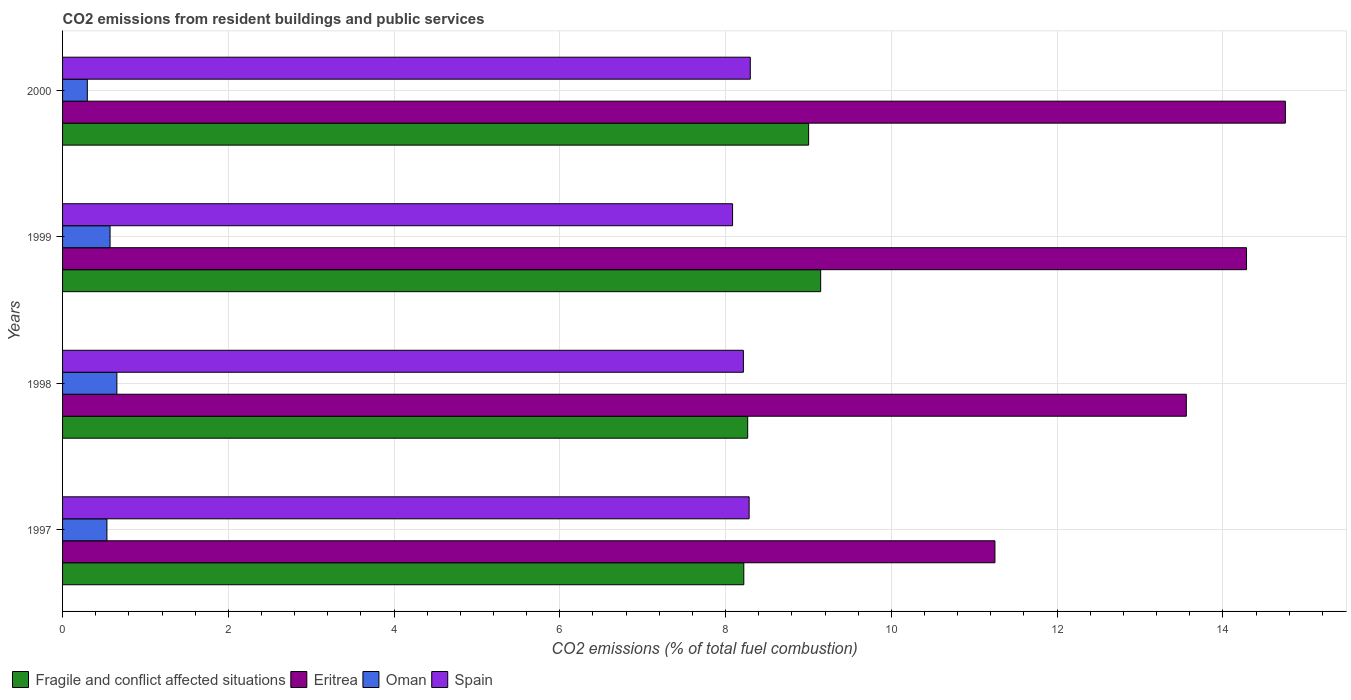How many different coloured bars are there?
Keep it short and to the point. 4. Are the number of bars per tick equal to the number of legend labels?
Your answer should be compact. Yes. Are the number of bars on each tick of the Y-axis equal?
Your answer should be compact. Yes. What is the label of the 1st group of bars from the top?
Offer a very short reply. 2000. What is the total CO2 emitted in Oman in 1999?
Your response must be concise. 0.57. Across all years, what is the maximum total CO2 emitted in Fragile and conflict affected situations?
Your answer should be very brief. 9.15. Across all years, what is the minimum total CO2 emitted in Oman?
Give a very brief answer. 0.3. In which year was the total CO2 emitted in Spain maximum?
Ensure brevity in your answer.  2000. What is the total total CO2 emitted in Oman in the graph?
Ensure brevity in your answer.  2.06. What is the difference between the total CO2 emitted in Eritrea in 1997 and that in 1999?
Your answer should be very brief. -3.04. What is the difference between the total CO2 emitted in Oman in 1998 and the total CO2 emitted in Eritrea in 1999?
Provide a succinct answer. -13.63. What is the average total CO2 emitted in Fragile and conflict affected situations per year?
Your answer should be compact. 8.66. In the year 1999, what is the difference between the total CO2 emitted in Spain and total CO2 emitted in Fragile and conflict affected situations?
Your response must be concise. -1.06. In how many years, is the total CO2 emitted in Spain greater than 2.8 ?
Provide a short and direct response. 4. What is the ratio of the total CO2 emitted in Oman in 1999 to that in 2000?
Offer a very short reply. 1.92. Is the total CO2 emitted in Eritrea in 1997 less than that in 1999?
Offer a terse response. Yes. What is the difference between the highest and the second highest total CO2 emitted in Fragile and conflict affected situations?
Offer a very short reply. 0.15. What is the difference between the highest and the lowest total CO2 emitted in Fragile and conflict affected situations?
Your response must be concise. 0.93. In how many years, is the total CO2 emitted in Oman greater than the average total CO2 emitted in Oman taken over all years?
Keep it short and to the point. 3. What does the 1st bar from the top in 1999 represents?
Give a very brief answer. Spain. What does the 2nd bar from the bottom in 1998 represents?
Keep it short and to the point. Eritrea. How many years are there in the graph?
Give a very brief answer. 4. Are the values on the major ticks of X-axis written in scientific E-notation?
Your response must be concise. No. Does the graph contain grids?
Provide a short and direct response. Yes. Where does the legend appear in the graph?
Ensure brevity in your answer.  Bottom left. How are the legend labels stacked?
Provide a succinct answer. Horizontal. What is the title of the graph?
Provide a short and direct response. CO2 emissions from resident buildings and public services. What is the label or title of the X-axis?
Make the answer very short. CO2 emissions (% of total fuel combustion). What is the label or title of the Y-axis?
Ensure brevity in your answer.  Years. What is the CO2 emissions (% of total fuel combustion) in Fragile and conflict affected situations in 1997?
Your answer should be compact. 8.22. What is the CO2 emissions (% of total fuel combustion) of Eritrea in 1997?
Your answer should be compact. 11.25. What is the CO2 emissions (% of total fuel combustion) in Oman in 1997?
Provide a short and direct response. 0.54. What is the CO2 emissions (% of total fuel combustion) of Spain in 1997?
Your answer should be very brief. 8.28. What is the CO2 emissions (% of total fuel combustion) of Fragile and conflict affected situations in 1998?
Keep it short and to the point. 8.27. What is the CO2 emissions (% of total fuel combustion) of Eritrea in 1998?
Your response must be concise. 13.56. What is the CO2 emissions (% of total fuel combustion) in Oman in 1998?
Provide a succinct answer. 0.66. What is the CO2 emissions (% of total fuel combustion) in Spain in 1998?
Keep it short and to the point. 8.21. What is the CO2 emissions (% of total fuel combustion) of Fragile and conflict affected situations in 1999?
Ensure brevity in your answer.  9.15. What is the CO2 emissions (% of total fuel combustion) in Eritrea in 1999?
Your answer should be very brief. 14.29. What is the CO2 emissions (% of total fuel combustion) in Oman in 1999?
Your answer should be very brief. 0.57. What is the CO2 emissions (% of total fuel combustion) of Spain in 1999?
Make the answer very short. 8.08. What is the CO2 emissions (% of total fuel combustion) in Fragile and conflict affected situations in 2000?
Offer a terse response. 9. What is the CO2 emissions (% of total fuel combustion) in Eritrea in 2000?
Give a very brief answer. 14.75. What is the CO2 emissions (% of total fuel combustion) of Oman in 2000?
Provide a succinct answer. 0.3. What is the CO2 emissions (% of total fuel combustion) of Spain in 2000?
Your answer should be compact. 8.3. Across all years, what is the maximum CO2 emissions (% of total fuel combustion) of Fragile and conflict affected situations?
Your response must be concise. 9.15. Across all years, what is the maximum CO2 emissions (% of total fuel combustion) of Eritrea?
Offer a very short reply. 14.75. Across all years, what is the maximum CO2 emissions (% of total fuel combustion) in Oman?
Provide a short and direct response. 0.66. Across all years, what is the maximum CO2 emissions (% of total fuel combustion) of Spain?
Offer a terse response. 8.3. Across all years, what is the minimum CO2 emissions (% of total fuel combustion) of Fragile and conflict affected situations?
Offer a very short reply. 8.22. Across all years, what is the minimum CO2 emissions (% of total fuel combustion) of Eritrea?
Offer a very short reply. 11.25. Across all years, what is the minimum CO2 emissions (% of total fuel combustion) of Oman?
Your response must be concise. 0.3. Across all years, what is the minimum CO2 emissions (% of total fuel combustion) in Spain?
Your answer should be very brief. 8.08. What is the total CO2 emissions (% of total fuel combustion) in Fragile and conflict affected situations in the graph?
Provide a short and direct response. 34.64. What is the total CO2 emissions (% of total fuel combustion) in Eritrea in the graph?
Offer a very short reply. 53.85. What is the total CO2 emissions (% of total fuel combustion) in Oman in the graph?
Make the answer very short. 2.06. What is the total CO2 emissions (% of total fuel combustion) in Spain in the graph?
Keep it short and to the point. 32.88. What is the difference between the CO2 emissions (% of total fuel combustion) of Fragile and conflict affected situations in 1997 and that in 1998?
Make the answer very short. -0.05. What is the difference between the CO2 emissions (% of total fuel combustion) of Eritrea in 1997 and that in 1998?
Offer a terse response. -2.31. What is the difference between the CO2 emissions (% of total fuel combustion) of Oman in 1997 and that in 1998?
Keep it short and to the point. -0.12. What is the difference between the CO2 emissions (% of total fuel combustion) in Spain in 1997 and that in 1998?
Your response must be concise. 0.07. What is the difference between the CO2 emissions (% of total fuel combustion) in Fragile and conflict affected situations in 1997 and that in 1999?
Offer a terse response. -0.93. What is the difference between the CO2 emissions (% of total fuel combustion) of Eritrea in 1997 and that in 1999?
Offer a terse response. -3.04. What is the difference between the CO2 emissions (% of total fuel combustion) in Oman in 1997 and that in 1999?
Your answer should be very brief. -0.04. What is the difference between the CO2 emissions (% of total fuel combustion) of Spain in 1997 and that in 1999?
Ensure brevity in your answer.  0.2. What is the difference between the CO2 emissions (% of total fuel combustion) of Fragile and conflict affected situations in 1997 and that in 2000?
Your response must be concise. -0.78. What is the difference between the CO2 emissions (% of total fuel combustion) in Eritrea in 1997 and that in 2000?
Keep it short and to the point. -3.5. What is the difference between the CO2 emissions (% of total fuel combustion) of Oman in 1997 and that in 2000?
Offer a terse response. 0.24. What is the difference between the CO2 emissions (% of total fuel combustion) in Spain in 1997 and that in 2000?
Your answer should be compact. -0.01. What is the difference between the CO2 emissions (% of total fuel combustion) of Fragile and conflict affected situations in 1998 and that in 1999?
Give a very brief answer. -0.88. What is the difference between the CO2 emissions (% of total fuel combustion) of Eritrea in 1998 and that in 1999?
Offer a very short reply. -0.73. What is the difference between the CO2 emissions (% of total fuel combustion) in Oman in 1998 and that in 1999?
Give a very brief answer. 0.08. What is the difference between the CO2 emissions (% of total fuel combustion) in Spain in 1998 and that in 1999?
Your answer should be very brief. 0.13. What is the difference between the CO2 emissions (% of total fuel combustion) of Fragile and conflict affected situations in 1998 and that in 2000?
Your answer should be very brief. -0.74. What is the difference between the CO2 emissions (% of total fuel combustion) in Eritrea in 1998 and that in 2000?
Provide a short and direct response. -1.19. What is the difference between the CO2 emissions (% of total fuel combustion) of Oman in 1998 and that in 2000?
Your response must be concise. 0.36. What is the difference between the CO2 emissions (% of total fuel combustion) of Spain in 1998 and that in 2000?
Ensure brevity in your answer.  -0.08. What is the difference between the CO2 emissions (% of total fuel combustion) of Fragile and conflict affected situations in 1999 and that in 2000?
Keep it short and to the point. 0.15. What is the difference between the CO2 emissions (% of total fuel combustion) of Eritrea in 1999 and that in 2000?
Your answer should be very brief. -0.47. What is the difference between the CO2 emissions (% of total fuel combustion) in Oman in 1999 and that in 2000?
Provide a short and direct response. 0.27. What is the difference between the CO2 emissions (% of total fuel combustion) in Spain in 1999 and that in 2000?
Provide a short and direct response. -0.21. What is the difference between the CO2 emissions (% of total fuel combustion) in Fragile and conflict affected situations in 1997 and the CO2 emissions (% of total fuel combustion) in Eritrea in 1998?
Your response must be concise. -5.34. What is the difference between the CO2 emissions (% of total fuel combustion) in Fragile and conflict affected situations in 1997 and the CO2 emissions (% of total fuel combustion) in Oman in 1998?
Provide a succinct answer. 7.56. What is the difference between the CO2 emissions (% of total fuel combustion) of Fragile and conflict affected situations in 1997 and the CO2 emissions (% of total fuel combustion) of Spain in 1998?
Provide a short and direct response. 0.01. What is the difference between the CO2 emissions (% of total fuel combustion) of Eritrea in 1997 and the CO2 emissions (% of total fuel combustion) of Oman in 1998?
Provide a short and direct response. 10.59. What is the difference between the CO2 emissions (% of total fuel combustion) in Eritrea in 1997 and the CO2 emissions (% of total fuel combustion) in Spain in 1998?
Make the answer very short. 3.04. What is the difference between the CO2 emissions (% of total fuel combustion) in Oman in 1997 and the CO2 emissions (% of total fuel combustion) in Spain in 1998?
Your answer should be compact. -7.68. What is the difference between the CO2 emissions (% of total fuel combustion) of Fragile and conflict affected situations in 1997 and the CO2 emissions (% of total fuel combustion) of Eritrea in 1999?
Ensure brevity in your answer.  -6.07. What is the difference between the CO2 emissions (% of total fuel combustion) in Fragile and conflict affected situations in 1997 and the CO2 emissions (% of total fuel combustion) in Oman in 1999?
Your answer should be compact. 7.65. What is the difference between the CO2 emissions (% of total fuel combustion) in Fragile and conflict affected situations in 1997 and the CO2 emissions (% of total fuel combustion) in Spain in 1999?
Provide a succinct answer. 0.14. What is the difference between the CO2 emissions (% of total fuel combustion) in Eritrea in 1997 and the CO2 emissions (% of total fuel combustion) in Oman in 1999?
Ensure brevity in your answer.  10.68. What is the difference between the CO2 emissions (% of total fuel combustion) of Eritrea in 1997 and the CO2 emissions (% of total fuel combustion) of Spain in 1999?
Offer a terse response. 3.17. What is the difference between the CO2 emissions (% of total fuel combustion) of Oman in 1997 and the CO2 emissions (% of total fuel combustion) of Spain in 1999?
Your answer should be very brief. -7.55. What is the difference between the CO2 emissions (% of total fuel combustion) of Fragile and conflict affected situations in 1997 and the CO2 emissions (% of total fuel combustion) of Eritrea in 2000?
Make the answer very short. -6.53. What is the difference between the CO2 emissions (% of total fuel combustion) in Fragile and conflict affected situations in 1997 and the CO2 emissions (% of total fuel combustion) in Oman in 2000?
Your answer should be compact. 7.92. What is the difference between the CO2 emissions (% of total fuel combustion) in Fragile and conflict affected situations in 1997 and the CO2 emissions (% of total fuel combustion) in Spain in 2000?
Ensure brevity in your answer.  -0.08. What is the difference between the CO2 emissions (% of total fuel combustion) of Eritrea in 1997 and the CO2 emissions (% of total fuel combustion) of Oman in 2000?
Give a very brief answer. 10.95. What is the difference between the CO2 emissions (% of total fuel combustion) of Eritrea in 1997 and the CO2 emissions (% of total fuel combustion) of Spain in 2000?
Give a very brief answer. 2.95. What is the difference between the CO2 emissions (% of total fuel combustion) in Oman in 1997 and the CO2 emissions (% of total fuel combustion) in Spain in 2000?
Your response must be concise. -7.76. What is the difference between the CO2 emissions (% of total fuel combustion) in Fragile and conflict affected situations in 1998 and the CO2 emissions (% of total fuel combustion) in Eritrea in 1999?
Your response must be concise. -6.02. What is the difference between the CO2 emissions (% of total fuel combustion) in Fragile and conflict affected situations in 1998 and the CO2 emissions (% of total fuel combustion) in Oman in 1999?
Your response must be concise. 7.69. What is the difference between the CO2 emissions (% of total fuel combustion) in Fragile and conflict affected situations in 1998 and the CO2 emissions (% of total fuel combustion) in Spain in 1999?
Offer a very short reply. 0.18. What is the difference between the CO2 emissions (% of total fuel combustion) of Eritrea in 1998 and the CO2 emissions (% of total fuel combustion) of Oman in 1999?
Keep it short and to the point. 12.99. What is the difference between the CO2 emissions (% of total fuel combustion) in Eritrea in 1998 and the CO2 emissions (% of total fuel combustion) in Spain in 1999?
Ensure brevity in your answer.  5.47. What is the difference between the CO2 emissions (% of total fuel combustion) in Oman in 1998 and the CO2 emissions (% of total fuel combustion) in Spain in 1999?
Provide a short and direct response. -7.43. What is the difference between the CO2 emissions (% of total fuel combustion) of Fragile and conflict affected situations in 1998 and the CO2 emissions (% of total fuel combustion) of Eritrea in 2000?
Ensure brevity in your answer.  -6.49. What is the difference between the CO2 emissions (% of total fuel combustion) in Fragile and conflict affected situations in 1998 and the CO2 emissions (% of total fuel combustion) in Oman in 2000?
Offer a terse response. 7.97. What is the difference between the CO2 emissions (% of total fuel combustion) of Fragile and conflict affected situations in 1998 and the CO2 emissions (% of total fuel combustion) of Spain in 2000?
Provide a short and direct response. -0.03. What is the difference between the CO2 emissions (% of total fuel combustion) of Eritrea in 1998 and the CO2 emissions (% of total fuel combustion) of Oman in 2000?
Give a very brief answer. 13.26. What is the difference between the CO2 emissions (% of total fuel combustion) of Eritrea in 1998 and the CO2 emissions (% of total fuel combustion) of Spain in 2000?
Make the answer very short. 5.26. What is the difference between the CO2 emissions (% of total fuel combustion) in Oman in 1998 and the CO2 emissions (% of total fuel combustion) in Spain in 2000?
Keep it short and to the point. -7.64. What is the difference between the CO2 emissions (% of total fuel combustion) of Fragile and conflict affected situations in 1999 and the CO2 emissions (% of total fuel combustion) of Eritrea in 2000?
Your answer should be compact. -5.61. What is the difference between the CO2 emissions (% of total fuel combustion) in Fragile and conflict affected situations in 1999 and the CO2 emissions (% of total fuel combustion) in Oman in 2000?
Offer a very short reply. 8.85. What is the difference between the CO2 emissions (% of total fuel combustion) of Fragile and conflict affected situations in 1999 and the CO2 emissions (% of total fuel combustion) of Spain in 2000?
Your response must be concise. 0.85. What is the difference between the CO2 emissions (% of total fuel combustion) in Eritrea in 1999 and the CO2 emissions (% of total fuel combustion) in Oman in 2000?
Keep it short and to the point. 13.99. What is the difference between the CO2 emissions (% of total fuel combustion) in Eritrea in 1999 and the CO2 emissions (% of total fuel combustion) in Spain in 2000?
Your answer should be very brief. 5.99. What is the difference between the CO2 emissions (% of total fuel combustion) in Oman in 1999 and the CO2 emissions (% of total fuel combustion) in Spain in 2000?
Make the answer very short. -7.72. What is the average CO2 emissions (% of total fuel combustion) in Fragile and conflict affected situations per year?
Your answer should be very brief. 8.66. What is the average CO2 emissions (% of total fuel combustion) of Eritrea per year?
Make the answer very short. 13.46. What is the average CO2 emissions (% of total fuel combustion) in Oman per year?
Provide a succinct answer. 0.52. What is the average CO2 emissions (% of total fuel combustion) in Spain per year?
Your answer should be very brief. 8.22. In the year 1997, what is the difference between the CO2 emissions (% of total fuel combustion) of Fragile and conflict affected situations and CO2 emissions (% of total fuel combustion) of Eritrea?
Keep it short and to the point. -3.03. In the year 1997, what is the difference between the CO2 emissions (% of total fuel combustion) in Fragile and conflict affected situations and CO2 emissions (% of total fuel combustion) in Oman?
Give a very brief answer. 7.68. In the year 1997, what is the difference between the CO2 emissions (% of total fuel combustion) of Fragile and conflict affected situations and CO2 emissions (% of total fuel combustion) of Spain?
Your response must be concise. -0.06. In the year 1997, what is the difference between the CO2 emissions (% of total fuel combustion) in Eritrea and CO2 emissions (% of total fuel combustion) in Oman?
Your answer should be compact. 10.71. In the year 1997, what is the difference between the CO2 emissions (% of total fuel combustion) in Eritrea and CO2 emissions (% of total fuel combustion) in Spain?
Make the answer very short. 2.97. In the year 1997, what is the difference between the CO2 emissions (% of total fuel combustion) of Oman and CO2 emissions (% of total fuel combustion) of Spain?
Your response must be concise. -7.75. In the year 1998, what is the difference between the CO2 emissions (% of total fuel combustion) in Fragile and conflict affected situations and CO2 emissions (% of total fuel combustion) in Eritrea?
Provide a succinct answer. -5.29. In the year 1998, what is the difference between the CO2 emissions (% of total fuel combustion) of Fragile and conflict affected situations and CO2 emissions (% of total fuel combustion) of Oman?
Your answer should be compact. 7.61. In the year 1998, what is the difference between the CO2 emissions (% of total fuel combustion) in Fragile and conflict affected situations and CO2 emissions (% of total fuel combustion) in Spain?
Provide a short and direct response. 0.05. In the year 1998, what is the difference between the CO2 emissions (% of total fuel combustion) of Eritrea and CO2 emissions (% of total fuel combustion) of Oman?
Provide a succinct answer. 12.9. In the year 1998, what is the difference between the CO2 emissions (% of total fuel combustion) in Eritrea and CO2 emissions (% of total fuel combustion) in Spain?
Your response must be concise. 5.34. In the year 1998, what is the difference between the CO2 emissions (% of total fuel combustion) in Oman and CO2 emissions (% of total fuel combustion) in Spain?
Provide a short and direct response. -7.56. In the year 1999, what is the difference between the CO2 emissions (% of total fuel combustion) of Fragile and conflict affected situations and CO2 emissions (% of total fuel combustion) of Eritrea?
Keep it short and to the point. -5.14. In the year 1999, what is the difference between the CO2 emissions (% of total fuel combustion) in Fragile and conflict affected situations and CO2 emissions (% of total fuel combustion) in Oman?
Keep it short and to the point. 8.57. In the year 1999, what is the difference between the CO2 emissions (% of total fuel combustion) in Fragile and conflict affected situations and CO2 emissions (% of total fuel combustion) in Spain?
Make the answer very short. 1.06. In the year 1999, what is the difference between the CO2 emissions (% of total fuel combustion) in Eritrea and CO2 emissions (% of total fuel combustion) in Oman?
Your response must be concise. 13.71. In the year 1999, what is the difference between the CO2 emissions (% of total fuel combustion) in Eritrea and CO2 emissions (% of total fuel combustion) in Spain?
Your response must be concise. 6.2. In the year 1999, what is the difference between the CO2 emissions (% of total fuel combustion) in Oman and CO2 emissions (% of total fuel combustion) in Spain?
Your answer should be compact. -7.51. In the year 2000, what is the difference between the CO2 emissions (% of total fuel combustion) of Fragile and conflict affected situations and CO2 emissions (% of total fuel combustion) of Eritrea?
Your answer should be compact. -5.75. In the year 2000, what is the difference between the CO2 emissions (% of total fuel combustion) in Fragile and conflict affected situations and CO2 emissions (% of total fuel combustion) in Oman?
Provide a succinct answer. 8.7. In the year 2000, what is the difference between the CO2 emissions (% of total fuel combustion) in Fragile and conflict affected situations and CO2 emissions (% of total fuel combustion) in Spain?
Give a very brief answer. 0.7. In the year 2000, what is the difference between the CO2 emissions (% of total fuel combustion) of Eritrea and CO2 emissions (% of total fuel combustion) of Oman?
Offer a very short reply. 14.46. In the year 2000, what is the difference between the CO2 emissions (% of total fuel combustion) in Eritrea and CO2 emissions (% of total fuel combustion) in Spain?
Ensure brevity in your answer.  6.46. In the year 2000, what is the difference between the CO2 emissions (% of total fuel combustion) of Oman and CO2 emissions (% of total fuel combustion) of Spain?
Offer a terse response. -8. What is the ratio of the CO2 emissions (% of total fuel combustion) of Fragile and conflict affected situations in 1997 to that in 1998?
Offer a very short reply. 0.99. What is the ratio of the CO2 emissions (% of total fuel combustion) in Eritrea in 1997 to that in 1998?
Make the answer very short. 0.83. What is the ratio of the CO2 emissions (% of total fuel combustion) in Oman in 1997 to that in 1998?
Ensure brevity in your answer.  0.82. What is the ratio of the CO2 emissions (% of total fuel combustion) in Spain in 1997 to that in 1998?
Keep it short and to the point. 1.01. What is the ratio of the CO2 emissions (% of total fuel combustion) in Fragile and conflict affected situations in 1997 to that in 1999?
Your answer should be compact. 0.9. What is the ratio of the CO2 emissions (% of total fuel combustion) of Eritrea in 1997 to that in 1999?
Your answer should be compact. 0.79. What is the ratio of the CO2 emissions (% of total fuel combustion) in Oman in 1997 to that in 1999?
Your response must be concise. 0.93. What is the ratio of the CO2 emissions (% of total fuel combustion) in Spain in 1997 to that in 1999?
Keep it short and to the point. 1.02. What is the ratio of the CO2 emissions (% of total fuel combustion) in Fragile and conflict affected situations in 1997 to that in 2000?
Your response must be concise. 0.91. What is the ratio of the CO2 emissions (% of total fuel combustion) of Eritrea in 1997 to that in 2000?
Your response must be concise. 0.76. What is the ratio of the CO2 emissions (% of total fuel combustion) in Oman in 1997 to that in 2000?
Make the answer very short. 1.79. What is the ratio of the CO2 emissions (% of total fuel combustion) of Spain in 1997 to that in 2000?
Provide a short and direct response. 1. What is the ratio of the CO2 emissions (% of total fuel combustion) of Fragile and conflict affected situations in 1998 to that in 1999?
Offer a terse response. 0.9. What is the ratio of the CO2 emissions (% of total fuel combustion) in Eritrea in 1998 to that in 1999?
Offer a terse response. 0.95. What is the ratio of the CO2 emissions (% of total fuel combustion) of Oman in 1998 to that in 1999?
Your answer should be compact. 1.14. What is the ratio of the CO2 emissions (% of total fuel combustion) in Spain in 1998 to that in 1999?
Your answer should be compact. 1.02. What is the ratio of the CO2 emissions (% of total fuel combustion) in Fragile and conflict affected situations in 1998 to that in 2000?
Keep it short and to the point. 0.92. What is the ratio of the CO2 emissions (% of total fuel combustion) of Eritrea in 1998 to that in 2000?
Keep it short and to the point. 0.92. What is the ratio of the CO2 emissions (% of total fuel combustion) in Oman in 1998 to that in 2000?
Make the answer very short. 2.2. What is the ratio of the CO2 emissions (% of total fuel combustion) of Fragile and conflict affected situations in 1999 to that in 2000?
Offer a very short reply. 1.02. What is the ratio of the CO2 emissions (% of total fuel combustion) of Eritrea in 1999 to that in 2000?
Offer a terse response. 0.97. What is the ratio of the CO2 emissions (% of total fuel combustion) of Oman in 1999 to that in 2000?
Offer a very short reply. 1.92. What is the ratio of the CO2 emissions (% of total fuel combustion) in Spain in 1999 to that in 2000?
Keep it short and to the point. 0.97. What is the difference between the highest and the second highest CO2 emissions (% of total fuel combustion) of Fragile and conflict affected situations?
Provide a short and direct response. 0.15. What is the difference between the highest and the second highest CO2 emissions (% of total fuel combustion) of Eritrea?
Provide a short and direct response. 0.47. What is the difference between the highest and the second highest CO2 emissions (% of total fuel combustion) of Oman?
Provide a succinct answer. 0.08. What is the difference between the highest and the second highest CO2 emissions (% of total fuel combustion) of Spain?
Provide a succinct answer. 0.01. What is the difference between the highest and the lowest CO2 emissions (% of total fuel combustion) in Fragile and conflict affected situations?
Make the answer very short. 0.93. What is the difference between the highest and the lowest CO2 emissions (% of total fuel combustion) of Eritrea?
Ensure brevity in your answer.  3.5. What is the difference between the highest and the lowest CO2 emissions (% of total fuel combustion) of Oman?
Offer a terse response. 0.36. What is the difference between the highest and the lowest CO2 emissions (% of total fuel combustion) of Spain?
Provide a succinct answer. 0.21. 